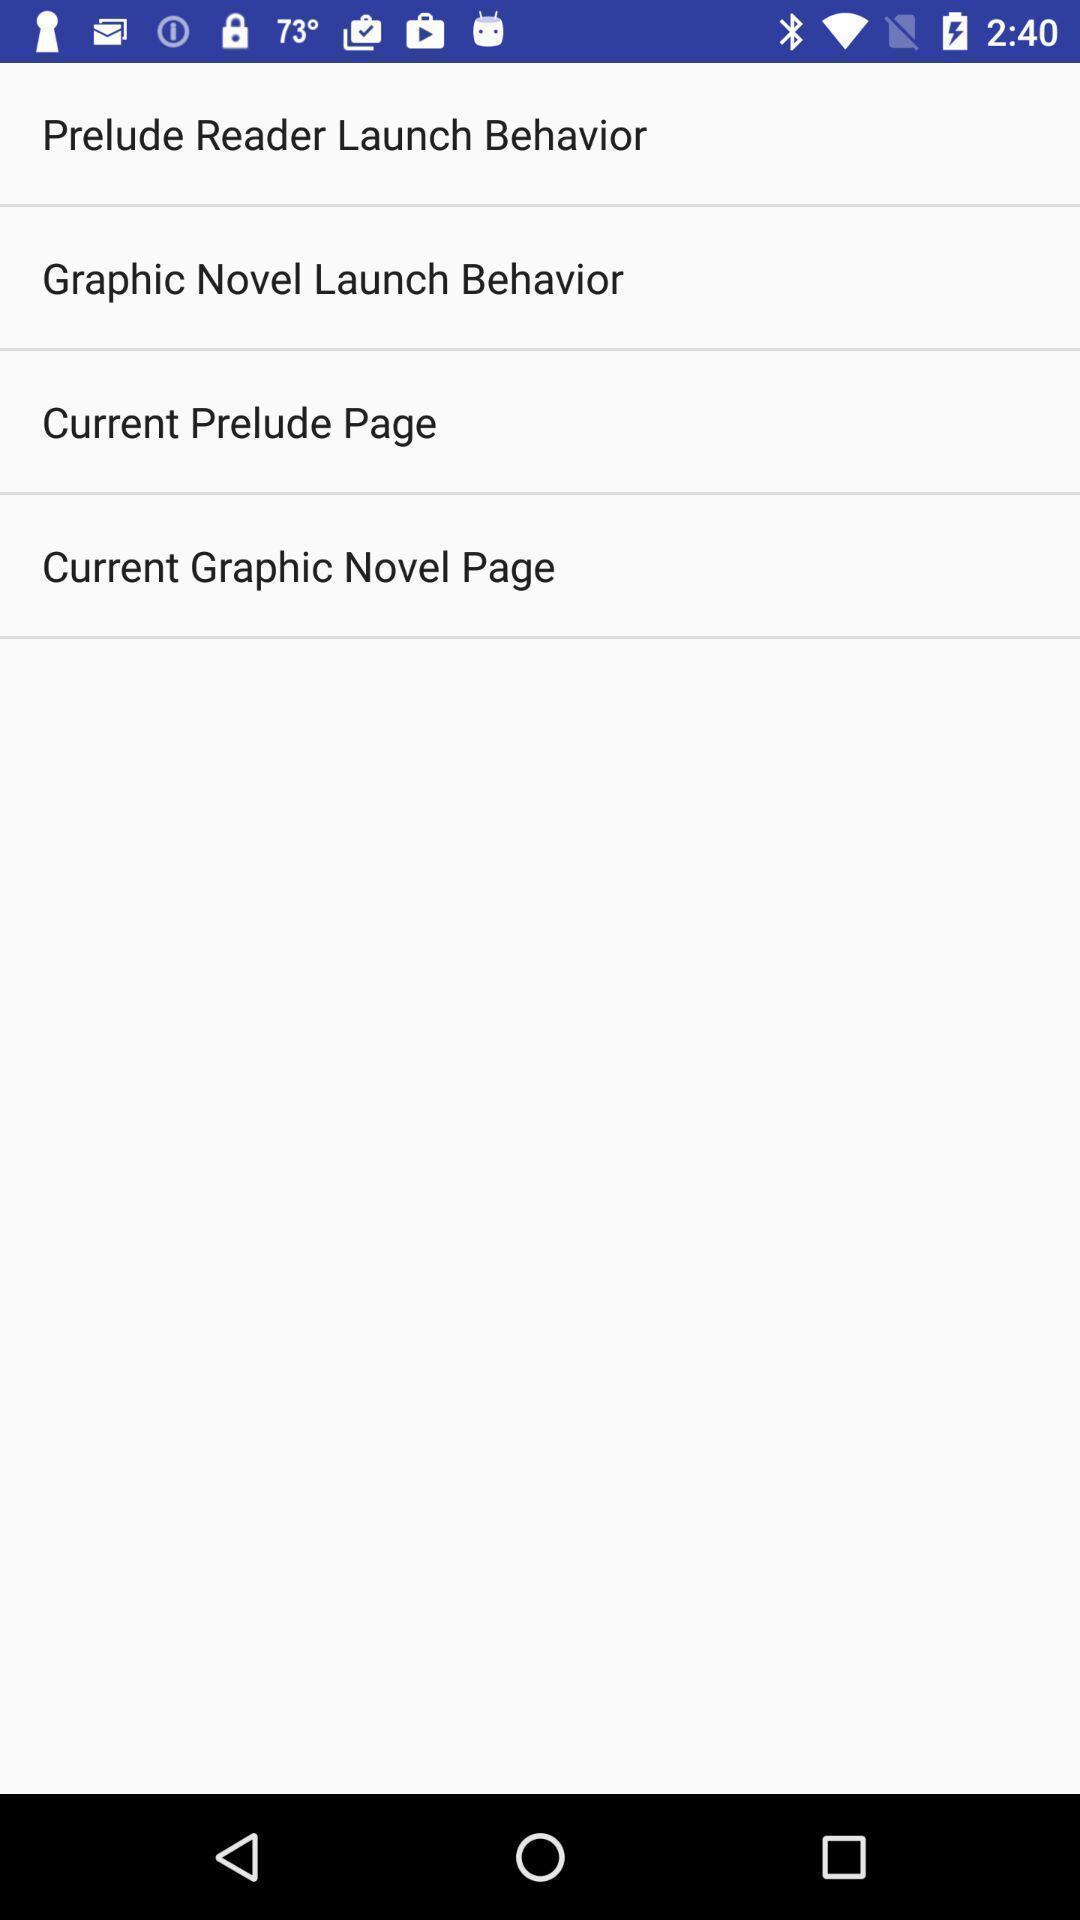Please provide a description for this image. Screen showing list of options. 